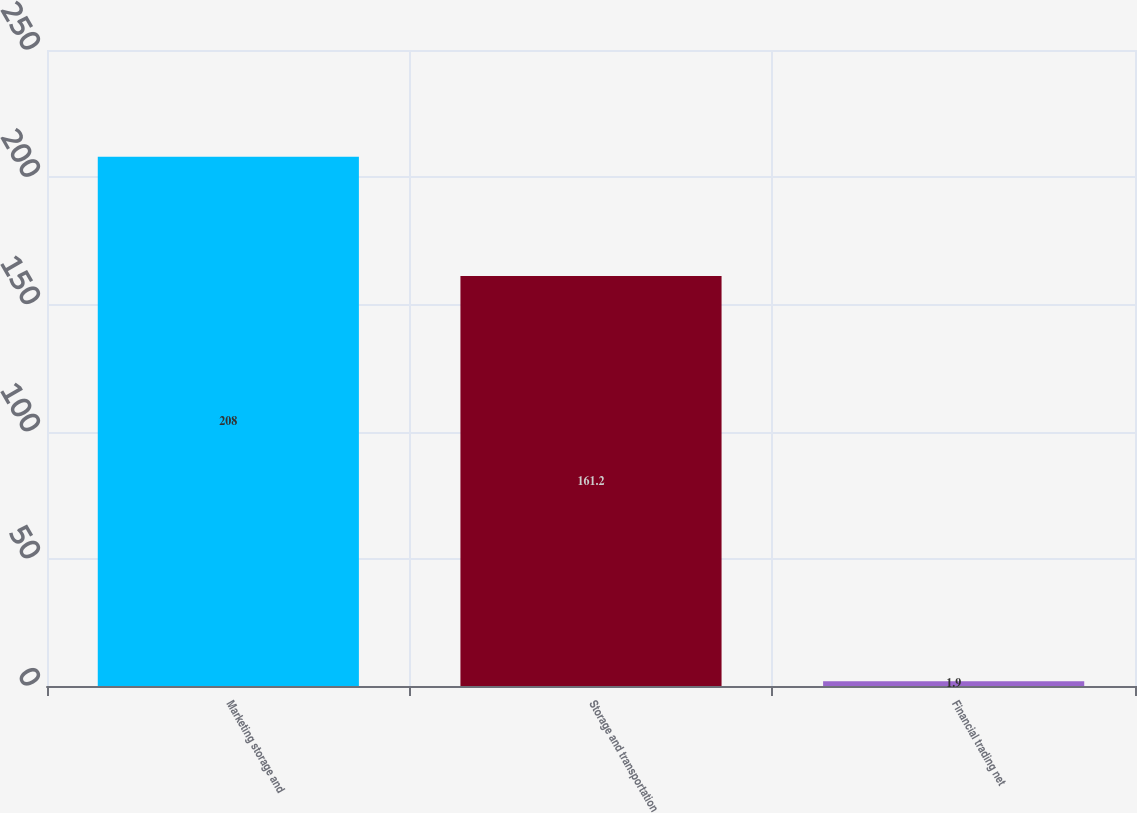Convert chart. <chart><loc_0><loc_0><loc_500><loc_500><bar_chart><fcel>Marketing storage and<fcel>Storage and transportation<fcel>Financial trading net<nl><fcel>208<fcel>161.2<fcel>1.9<nl></chart> 